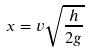<formula> <loc_0><loc_0><loc_500><loc_500>x = v \sqrt { \frac { h } { 2 g } }</formula> 